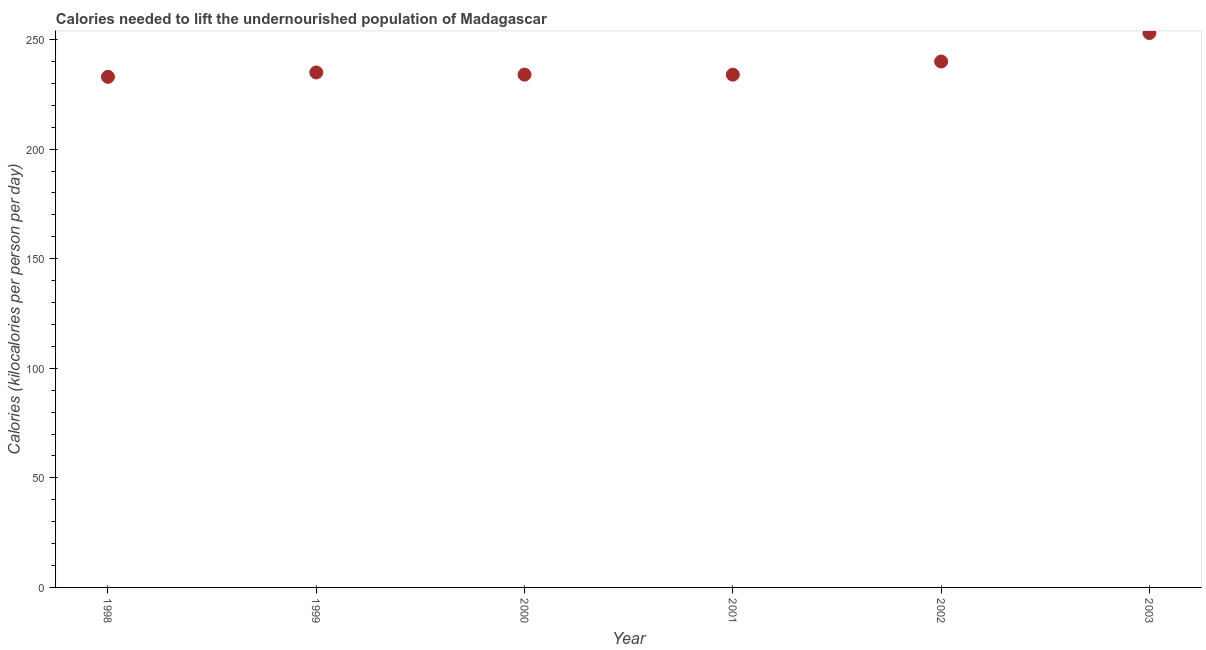What is the depth of food deficit in 1998?
Offer a very short reply. 233. Across all years, what is the maximum depth of food deficit?
Your answer should be very brief. 253. Across all years, what is the minimum depth of food deficit?
Give a very brief answer. 233. In which year was the depth of food deficit minimum?
Ensure brevity in your answer.  1998. What is the sum of the depth of food deficit?
Make the answer very short. 1429. What is the difference between the depth of food deficit in 1999 and 2001?
Your answer should be very brief. 1. What is the average depth of food deficit per year?
Provide a succinct answer. 238.17. What is the median depth of food deficit?
Provide a short and direct response. 234.5. In how many years, is the depth of food deficit greater than 20 kilocalories?
Keep it short and to the point. 6. What is the ratio of the depth of food deficit in 1998 to that in 2002?
Your answer should be very brief. 0.97. Is the depth of food deficit in 1999 less than that in 2001?
Offer a terse response. No. Is the difference between the depth of food deficit in 1999 and 2000 greater than the difference between any two years?
Keep it short and to the point. No. Is the sum of the depth of food deficit in 1999 and 2001 greater than the maximum depth of food deficit across all years?
Make the answer very short. Yes. What is the difference between the highest and the lowest depth of food deficit?
Provide a succinct answer. 20. In how many years, is the depth of food deficit greater than the average depth of food deficit taken over all years?
Provide a succinct answer. 2. Does the depth of food deficit monotonically increase over the years?
Your response must be concise. No. How many years are there in the graph?
Ensure brevity in your answer.  6. What is the difference between two consecutive major ticks on the Y-axis?
Give a very brief answer. 50. Are the values on the major ticks of Y-axis written in scientific E-notation?
Provide a succinct answer. No. Does the graph contain any zero values?
Your answer should be compact. No. What is the title of the graph?
Give a very brief answer. Calories needed to lift the undernourished population of Madagascar. What is the label or title of the X-axis?
Offer a very short reply. Year. What is the label or title of the Y-axis?
Provide a short and direct response. Calories (kilocalories per person per day). What is the Calories (kilocalories per person per day) in 1998?
Make the answer very short. 233. What is the Calories (kilocalories per person per day) in 1999?
Your response must be concise. 235. What is the Calories (kilocalories per person per day) in 2000?
Offer a terse response. 234. What is the Calories (kilocalories per person per day) in 2001?
Your answer should be compact. 234. What is the Calories (kilocalories per person per day) in 2002?
Offer a terse response. 240. What is the Calories (kilocalories per person per day) in 2003?
Ensure brevity in your answer.  253. What is the difference between the Calories (kilocalories per person per day) in 1998 and 1999?
Your response must be concise. -2. What is the difference between the Calories (kilocalories per person per day) in 1998 and 2000?
Make the answer very short. -1. What is the difference between the Calories (kilocalories per person per day) in 1998 and 2002?
Your answer should be very brief. -7. What is the difference between the Calories (kilocalories per person per day) in 1999 and 2002?
Provide a short and direct response. -5. What is the difference between the Calories (kilocalories per person per day) in 1999 and 2003?
Offer a very short reply. -18. What is the difference between the Calories (kilocalories per person per day) in 2000 and 2001?
Your answer should be compact. 0. What is the difference between the Calories (kilocalories per person per day) in 2000 and 2002?
Provide a succinct answer. -6. What is the difference between the Calories (kilocalories per person per day) in 2002 and 2003?
Provide a short and direct response. -13. What is the ratio of the Calories (kilocalories per person per day) in 1998 to that in 1999?
Your answer should be very brief. 0.99. What is the ratio of the Calories (kilocalories per person per day) in 1998 to that in 2000?
Make the answer very short. 1. What is the ratio of the Calories (kilocalories per person per day) in 1998 to that in 2001?
Make the answer very short. 1. What is the ratio of the Calories (kilocalories per person per day) in 1998 to that in 2003?
Provide a short and direct response. 0.92. What is the ratio of the Calories (kilocalories per person per day) in 1999 to that in 2003?
Your answer should be compact. 0.93. What is the ratio of the Calories (kilocalories per person per day) in 2000 to that in 2001?
Make the answer very short. 1. What is the ratio of the Calories (kilocalories per person per day) in 2000 to that in 2003?
Offer a very short reply. 0.93. What is the ratio of the Calories (kilocalories per person per day) in 2001 to that in 2002?
Make the answer very short. 0.97. What is the ratio of the Calories (kilocalories per person per day) in 2001 to that in 2003?
Give a very brief answer. 0.93. What is the ratio of the Calories (kilocalories per person per day) in 2002 to that in 2003?
Provide a short and direct response. 0.95. 